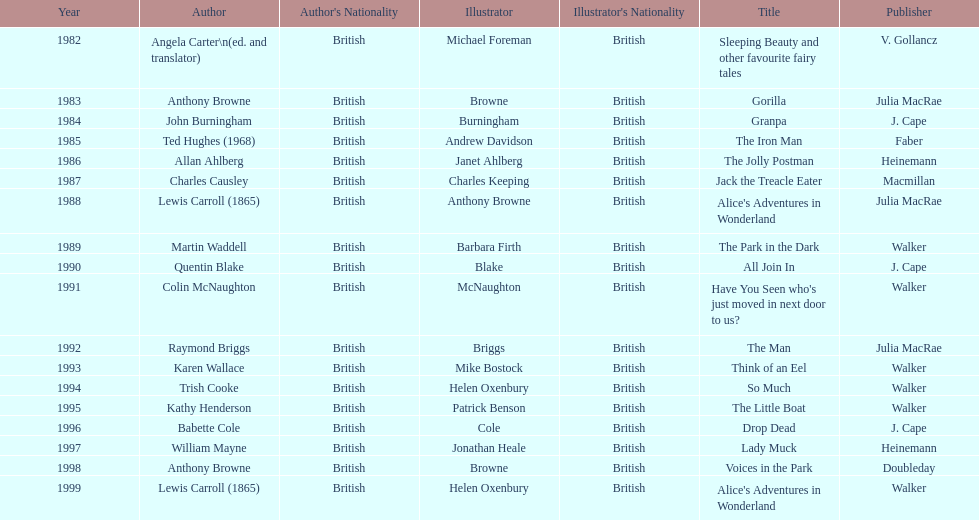Which illustrator was responsible for the last award winner? Helen Oxenbury. 